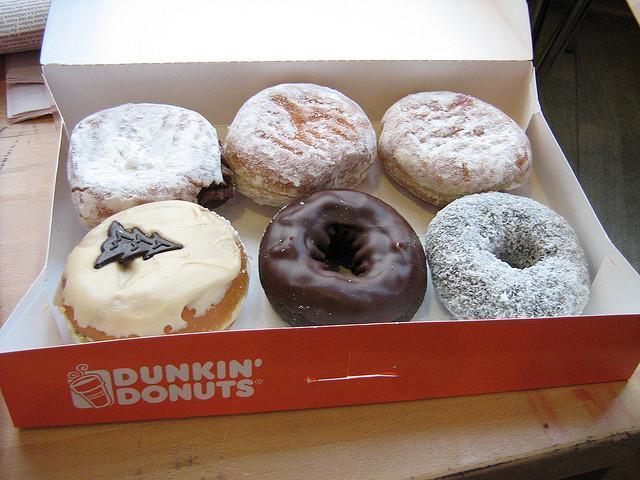How many donuts are there?
Give a very brief answer. 6. How many pieces of chocolate are on the plate?
Give a very brief answer. 1. How many doughnuts can be seen?
Give a very brief answer. 6. How many cakes are there?
Give a very brief answer. 1. How many people are wearing red?
Give a very brief answer. 0. 